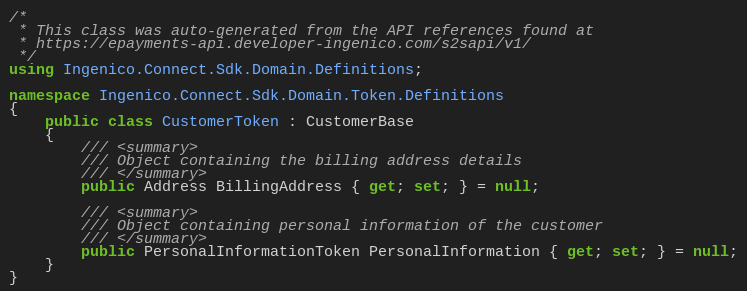Convert code to text. <code><loc_0><loc_0><loc_500><loc_500><_C#_>/*
 * This class was auto-generated from the API references found at
 * https://epayments-api.developer-ingenico.com/s2sapi/v1/
 */
using Ingenico.Connect.Sdk.Domain.Definitions;

namespace Ingenico.Connect.Sdk.Domain.Token.Definitions
{
    public class CustomerToken : CustomerBase
    {
        /// <summary>
        /// Object containing the billing address details
        /// </summary>
        public Address BillingAddress { get; set; } = null;

        /// <summary>
        /// Object containing personal information of the customer
        /// </summary>
        public PersonalInformationToken PersonalInformation { get; set; } = null;
    }
}
</code> 